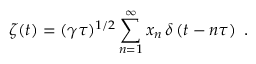Convert formula to latex. <formula><loc_0><loc_0><loc_500><loc_500>\zeta ( t ) = ( \gamma \tau ) ^ { 1 / 2 } \sum _ { n = 1 } ^ { \infty } x _ { n } \, \delta \left ( t - n \tau \right ) \ .</formula> 